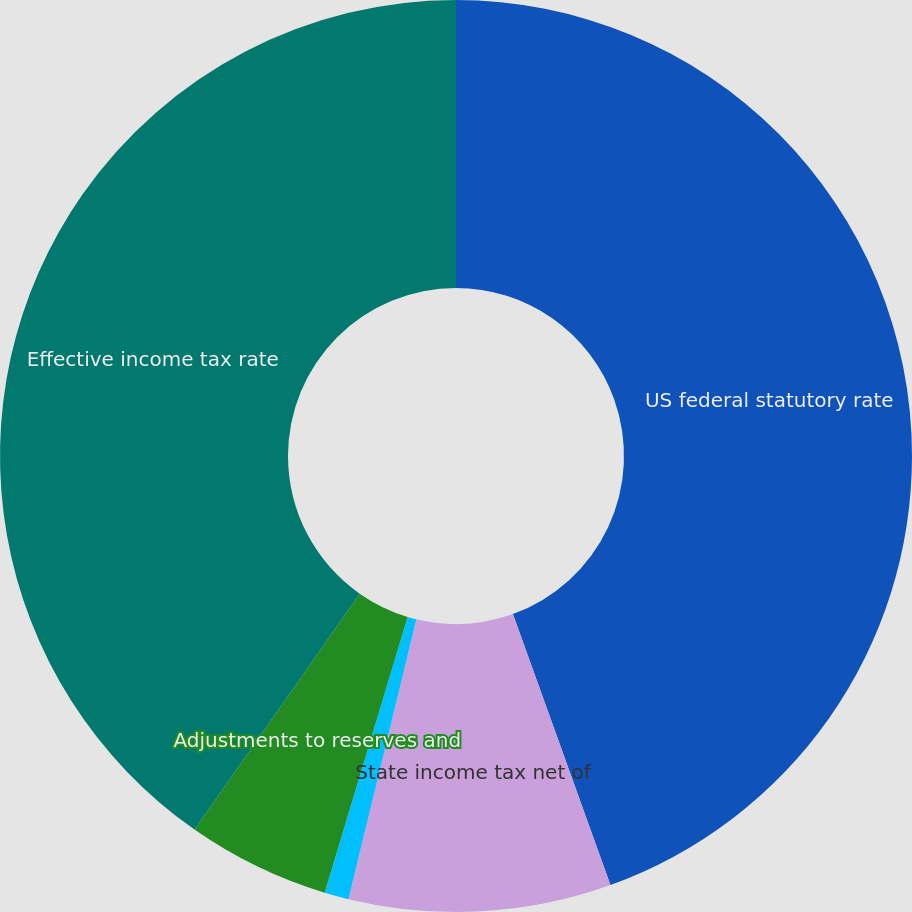Convert chart. <chart><loc_0><loc_0><loc_500><loc_500><pie_chart><fcel>US federal statutory rate<fcel>State income tax net of<fcel>Foreign and US tax effects<fcel>Adjustments to reserves and<fcel>Effective income tax rate<nl><fcel>44.5%<fcel>9.29%<fcel>0.86%<fcel>5.07%<fcel>40.28%<nl></chart> 